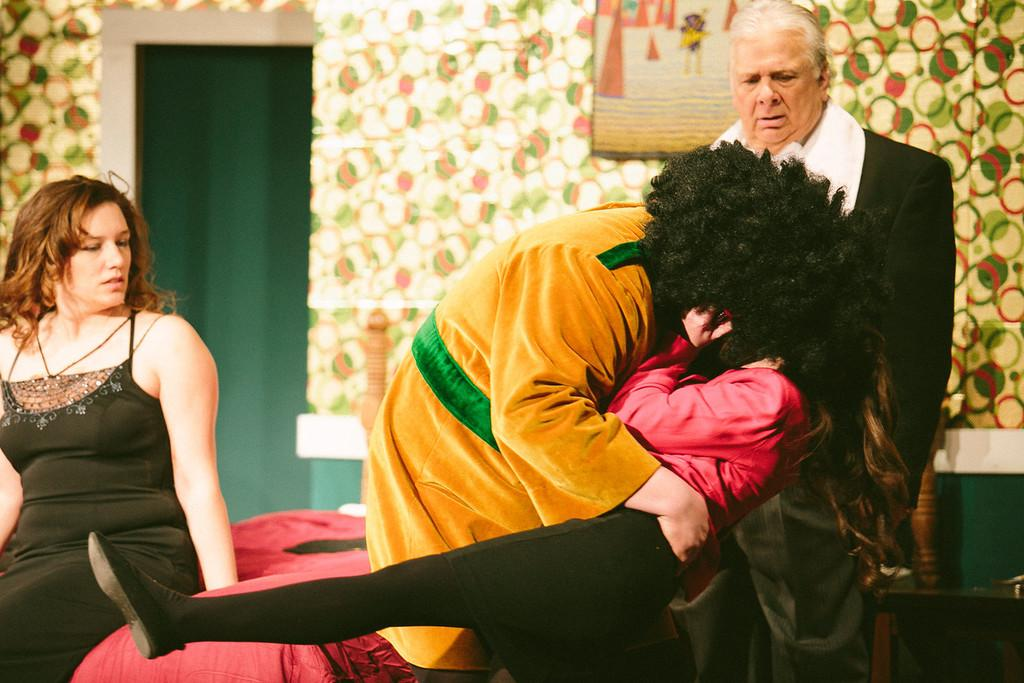How many people are present in the image? There are four people in the image. What is the woman doing in the image? The woman is sitting on a red cloth. What piece of furniture is present in the image? There is a table in the image. What can be seen on the wall in the background? There is a frame on the wall in the background. What type of instrument is the woman playing in the image? There is no instrument present in the image, and the woman is not playing any instrument. Can you hear the whistle in the image? There is no whistle present in the image, and therefore no sound can be heard. 